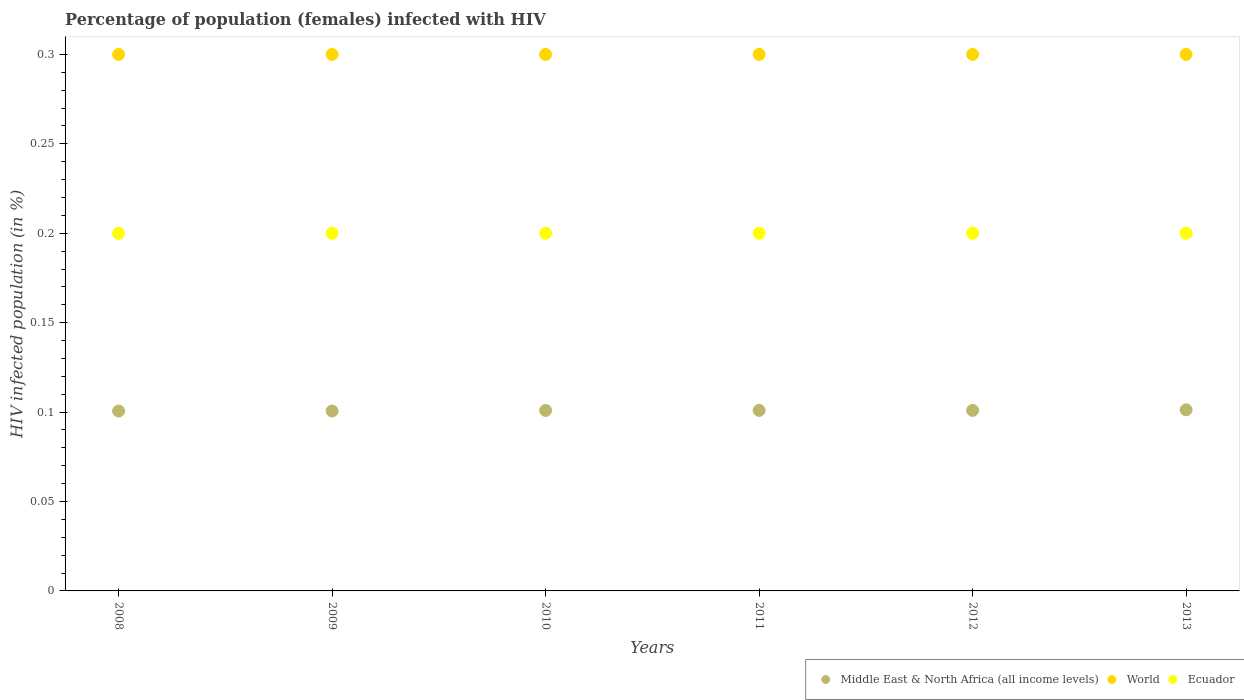Across all years, what is the maximum percentage of HIV infected female population in World?
Your answer should be compact. 0.3. Across all years, what is the minimum percentage of HIV infected female population in World?
Your response must be concise. 0.3. What is the total percentage of HIV infected female population in Middle East & North Africa (all income levels) in the graph?
Your response must be concise. 0.61. What is the difference between the percentage of HIV infected female population in Middle East & North Africa (all income levels) in 2009 and that in 2011?
Make the answer very short. -0. What is the difference between the percentage of HIV infected female population in Middle East & North Africa (all income levels) in 2009 and the percentage of HIV infected female population in World in 2010?
Ensure brevity in your answer.  -0.2. What is the average percentage of HIV infected female population in Middle East & North Africa (all income levels) per year?
Keep it short and to the point. 0.1. In the year 2009, what is the difference between the percentage of HIV infected female population in World and percentage of HIV infected female population in Middle East & North Africa (all income levels)?
Your answer should be very brief. 0.2. What is the ratio of the percentage of HIV infected female population in World in 2010 to that in 2013?
Make the answer very short. 1. What is the difference between the highest and the lowest percentage of HIV infected female population in World?
Keep it short and to the point. 0. Is the sum of the percentage of HIV infected female population in Middle East & North Africa (all income levels) in 2010 and 2012 greater than the maximum percentage of HIV infected female population in World across all years?
Your response must be concise. No. Does the percentage of HIV infected female population in World monotonically increase over the years?
Provide a short and direct response. No. Is the percentage of HIV infected female population in World strictly less than the percentage of HIV infected female population in Ecuador over the years?
Ensure brevity in your answer.  No. How many dotlines are there?
Offer a very short reply. 3. How many years are there in the graph?
Give a very brief answer. 6. What is the difference between two consecutive major ticks on the Y-axis?
Your answer should be compact. 0.05. Are the values on the major ticks of Y-axis written in scientific E-notation?
Provide a short and direct response. No. Does the graph contain grids?
Provide a short and direct response. No. How are the legend labels stacked?
Provide a succinct answer. Horizontal. What is the title of the graph?
Make the answer very short. Percentage of population (females) infected with HIV. Does "Benin" appear as one of the legend labels in the graph?
Give a very brief answer. No. What is the label or title of the X-axis?
Ensure brevity in your answer.  Years. What is the label or title of the Y-axis?
Provide a short and direct response. HIV infected population (in %). What is the HIV infected population (in %) in Middle East & North Africa (all income levels) in 2008?
Your answer should be compact. 0.1. What is the HIV infected population (in %) of Ecuador in 2008?
Your response must be concise. 0.2. What is the HIV infected population (in %) of Middle East & North Africa (all income levels) in 2009?
Offer a very short reply. 0.1. What is the HIV infected population (in %) of Middle East & North Africa (all income levels) in 2010?
Offer a very short reply. 0.1. What is the HIV infected population (in %) of Middle East & North Africa (all income levels) in 2011?
Your response must be concise. 0.1. What is the HIV infected population (in %) of Ecuador in 2011?
Keep it short and to the point. 0.2. What is the HIV infected population (in %) in Middle East & North Africa (all income levels) in 2012?
Offer a very short reply. 0.1. What is the HIV infected population (in %) of World in 2012?
Provide a short and direct response. 0.3. What is the HIV infected population (in %) in Ecuador in 2012?
Make the answer very short. 0.2. What is the HIV infected population (in %) of Middle East & North Africa (all income levels) in 2013?
Make the answer very short. 0.1. What is the HIV infected population (in %) in Ecuador in 2013?
Ensure brevity in your answer.  0.2. Across all years, what is the maximum HIV infected population (in %) in Middle East & North Africa (all income levels)?
Your response must be concise. 0.1. Across all years, what is the minimum HIV infected population (in %) of Middle East & North Africa (all income levels)?
Keep it short and to the point. 0.1. Across all years, what is the minimum HIV infected population (in %) in World?
Make the answer very short. 0.3. Across all years, what is the minimum HIV infected population (in %) in Ecuador?
Make the answer very short. 0.2. What is the total HIV infected population (in %) of Middle East & North Africa (all income levels) in the graph?
Give a very brief answer. 0.61. What is the total HIV infected population (in %) in World in the graph?
Offer a very short reply. 1.8. What is the difference between the HIV infected population (in %) of Middle East & North Africa (all income levels) in 2008 and that in 2009?
Your response must be concise. -0. What is the difference between the HIV infected population (in %) of World in 2008 and that in 2009?
Your answer should be very brief. 0. What is the difference between the HIV infected population (in %) of Ecuador in 2008 and that in 2009?
Your answer should be compact. 0. What is the difference between the HIV infected population (in %) in Middle East & North Africa (all income levels) in 2008 and that in 2010?
Provide a short and direct response. -0. What is the difference between the HIV infected population (in %) of World in 2008 and that in 2010?
Your answer should be compact. 0. What is the difference between the HIV infected population (in %) of Middle East & North Africa (all income levels) in 2008 and that in 2011?
Your answer should be very brief. -0. What is the difference between the HIV infected population (in %) of World in 2008 and that in 2011?
Your answer should be very brief. 0. What is the difference between the HIV infected population (in %) of Middle East & North Africa (all income levels) in 2008 and that in 2012?
Make the answer very short. -0. What is the difference between the HIV infected population (in %) in World in 2008 and that in 2012?
Your answer should be very brief. 0. What is the difference between the HIV infected population (in %) in Ecuador in 2008 and that in 2012?
Provide a short and direct response. 0. What is the difference between the HIV infected population (in %) in Middle East & North Africa (all income levels) in 2008 and that in 2013?
Make the answer very short. -0. What is the difference between the HIV infected population (in %) in Ecuador in 2008 and that in 2013?
Keep it short and to the point. 0. What is the difference between the HIV infected population (in %) in Middle East & North Africa (all income levels) in 2009 and that in 2010?
Ensure brevity in your answer.  -0. What is the difference between the HIV infected population (in %) in World in 2009 and that in 2010?
Give a very brief answer. 0. What is the difference between the HIV infected population (in %) of Middle East & North Africa (all income levels) in 2009 and that in 2011?
Your response must be concise. -0. What is the difference between the HIV infected population (in %) in Ecuador in 2009 and that in 2011?
Offer a terse response. 0. What is the difference between the HIV infected population (in %) in Middle East & North Africa (all income levels) in 2009 and that in 2012?
Provide a succinct answer. -0. What is the difference between the HIV infected population (in %) in Ecuador in 2009 and that in 2012?
Make the answer very short. 0. What is the difference between the HIV infected population (in %) of Middle East & North Africa (all income levels) in 2009 and that in 2013?
Give a very brief answer. -0. What is the difference between the HIV infected population (in %) of World in 2009 and that in 2013?
Your answer should be very brief. 0. What is the difference between the HIV infected population (in %) in Middle East & North Africa (all income levels) in 2010 and that in 2011?
Provide a short and direct response. -0. What is the difference between the HIV infected population (in %) in World in 2010 and that in 2011?
Give a very brief answer. 0. What is the difference between the HIV infected population (in %) of Middle East & North Africa (all income levels) in 2010 and that in 2013?
Keep it short and to the point. -0. What is the difference between the HIV infected population (in %) of Ecuador in 2010 and that in 2013?
Offer a terse response. 0. What is the difference between the HIV infected population (in %) in Middle East & North Africa (all income levels) in 2011 and that in 2013?
Make the answer very short. -0. What is the difference between the HIV infected population (in %) of Ecuador in 2011 and that in 2013?
Provide a succinct answer. 0. What is the difference between the HIV infected population (in %) of Middle East & North Africa (all income levels) in 2012 and that in 2013?
Ensure brevity in your answer.  -0. What is the difference between the HIV infected population (in %) in Ecuador in 2012 and that in 2013?
Provide a short and direct response. 0. What is the difference between the HIV infected population (in %) of Middle East & North Africa (all income levels) in 2008 and the HIV infected population (in %) of World in 2009?
Ensure brevity in your answer.  -0.2. What is the difference between the HIV infected population (in %) of Middle East & North Africa (all income levels) in 2008 and the HIV infected population (in %) of Ecuador in 2009?
Offer a very short reply. -0.1. What is the difference between the HIV infected population (in %) of World in 2008 and the HIV infected population (in %) of Ecuador in 2009?
Make the answer very short. 0.1. What is the difference between the HIV infected population (in %) of Middle East & North Africa (all income levels) in 2008 and the HIV infected population (in %) of World in 2010?
Give a very brief answer. -0.2. What is the difference between the HIV infected population (in %) of Middle East & North Africa (all income levels) in 2008 and the HIV infected population (in %) of Ecuador in 2010?
Provide a short and direct response. -0.1. What is the difference between the HIV infected population (in %) in Middle East & North Africa (all income levels) in 2008 and the HIV infected population (in %) in World in 2011?
Keep it short and to the point. -0.2. What is the difference between the HIV infected population (in %) in Middle East & North Africa (all income levels) in 2008 and the HIV infected population (in %) in Ecuador in 2011?
Offer a very short reply. -0.1. What is the difference between the HIV infected population (in %) of World in 2008 and the HIV infected population (in %) of Ecuador in 2011?
Make the answer very short. 0.1. What is the difference between the HIV infected population (in %) in Middle East & North Africa (all income levels) in 2008 and the HIV infected population (in %) in World in 2012?
Offer a very short reply. -0.2. What is the difference between the HIV infected population (in %) of Middle East & North Africa (all income levels) in 2008 and the HIV infected population (in %) of Ecuador in 2012?
Offer a very short reply. -0.1. What is the difference between the HIV infected population (in %) of Middle East & North Africa (all income levels) in 2008 and the HIV infected population (in %) of World in 2013?
Make the answer very short. -0.2. What is the difference between the HIV infected population (in %) of Middle East & North Africa (all income levels) in 2008 and the HIV infected population (in %) of Ecuador in 2013?
Your answer should be compact. -0.1. What is the difference between the HIV infected population (in %) of Middle East & North Africa (all income levels) in 2009 and the HIV infected population (in %) of World in 2010?
Provide a succinct answer. -0.2. What is the difference between the HIV infected population (in %) in Middle East & North Africa (all income levels) in 2009 and the HIV infected population (in %) in Ecuador in 2010?
Offer a very short reply. -0.1. What is the difference between the HIV infected population (in %) in Middle East & North Africa (all income levels) in 2009 and the HIV infected population (in %) in World in 2011?
Your response must be concise. -0.2. What is the difference between the HIV infected population (in %) in Middle East & North Africa (all income levels) in 2009 and the HIV infected population (in %) in Ecuador in 2011?
Your answer should be very brief. -0.1. What is the difference between the HIV infected population (in %) in Middle East & North Africa (all income levels) in 2009 and the HIV infected population (in %) in World in 2012?
Offer a very short reply. -0.2. What is the difference between the HIV infected population (in %) of Middle East & North Africa (all income levels) in 2009 and the HIV infected population (in %) of Ecuador in 2012?
Offer a very short reply. -0.1. What is the difference between the HIV infected population (in %) of Middle East & North Africa (all income levels) in 2009 and the HIV infected population (in %) of World in 2013?
Give a very brief answer. -0.2. What is the difference between the HIV infected population (in %) of Middle East & North Africa (all income levels) in 2009 and the HIV infected population (in %) of Ecuador in 2013?
Offer a very short reply. -0.1. What is the difference between the HIV infected population (in %) in Middle East & North Africa (all income levels) in 2010 and the HIV infected population (in %) in World in 2011?
Provide a succinct answer. -0.2. What is the difference between the HIV infected population (in %) in Middle East & North Africa (all income levels) in 2010 and the HIV infected population (in %) in Ecuador in 2011?
Ensure brevity in your answer.  -0.1. What is the difference between the HIV infected population (in %) in Middle East & North Africa (all income levels) in 2010 and the HIV infected population (in %) in World in 2012?
Ensure brevity in your answer.  -0.2. What is the difference between the HIV infected population (in %) in Middle East & North Africa (all income levels) in 2010 and the HIV infected population (in %) in Ecuador in 2012?
Your response must be concise. -0.1. What is the difference between the HIV infected population (in %) in World in 2010 and the HIV infected population (in %) in Ecuador in 2012?
Your answer should be very brief. 0.1. What is the difference between the HIV infected population (in %) of Middle East & North Africa (all income levels) in 2010 and the HIV infected population (in %) of World in 2013?
Give a very brief answer. -0.2. What is the difference between the HIV infected population (in %) of Middle East & North Africa (all income levels) in 2010 and the HIV infected population (in %) of Ecuador in 2013?
Your answer should be very brief. -0.1. What is the difference between the HIV infected population (in %) of World in 2010 and the HIV infected population (in %) of Ecuador in 2013?
Keep it short and to the point. 0.1. What is the difference between the HIV infected population (in %) of Middle East & North Africa (all income levels) in 2011 and the HIV infected population (in %) of World in 2012?
Offer a terse response. -0.2. What is the difference between the HIV infected population (in %) in Middle East & North Africa (all income levels) in 2011 and the HIV infected population (in %) in Ecuador in 2012?
Make the answer very short. -0.1. What is the difference between the HIV infected population (in %) in Middle East & North Africa (all income levels) in 2011 and the HIV infected population (in %) in World in 2013?
Your response must be concise. -0.2. What is the difference between the HIV infected population (in %) in Middle East & North Africa (all income levels) in 2011 and the HIV infected population (in %) in Ecuador in 2013?
Give a very brief answer. -0.1. What is the difference between the HIV infected population (in %) in Middle East & North Africa (all income levels) in 2012 and the HIV infected population (in %) in World in 2013?
Offer a very short reply. -0.2. What is the difference between the HIV infected population (in %) in Middle East & North Africa (all income levels) in 2012 and the HIV infected population (in %) in Ecuador in 2013?
Keep it short and to the point. -0.1. What is the difference between the HIV infected population (in %) of World in 2012 and the HIV infected population (in %) of Ecuador in 2013?
Give a very brief answer. 0.1. What is the average HIV infected population (in %) in Middle East & North Africa (all income levels) per year?
Provide a short and direct response. 0.1. What is the average HIV infected population (in %) of World per year?
Provide a short and direct response. 0.3. In the year 2008, what is the difference between the HIV infected population (in %) in Middle East & North Africa (all income levels) and HIV infected population (in %) in World?
Offer a very short reply. -0.2. In the year 2008, what is the difference between the HIV infected population (in %) of Middle East & North Africa (all income levels) and HIV infected population (in %) of Ecuador?
Your answer should be compact. -0.1. In the year 2008, what is the difference between the HIV infected population (in %) of World and HIV infected population (in %) of Ecuador?
Your response must be concise. 0.1. In the year 2009, what is the difference between the HIV infected population (in %) in Middle East & North Africa (all income levels) and HIV infected population (in %) in World?
Make the answer very short. -0.2. In the year 2009, what is the difference between the HIV infected population (in %) of Middle East & North Africa (all income levels) and HIV infected population (in %) of Ecuador?
Give a very brief answer. -0.1. In the year 2010, what is the difference between the HIV infected population (in %) of Middle East & North Africa (all income levels) and HIV infected population (in %) of World?
Keep it short and to the point. -0.2. In the year 2010, what is the difference between the HIV infected population (in %) of Middle East & North Africa (all income levels) and HIV infected population (in %) of Ecuador?
Offer a very short reply. -0.1. In the year 2011, what is the difference between the HIV infected population (in %) in Middle East & North Africa (all income levels) and HIV infected population (in %) in World?
Your answer should be very brief. -0.2. In the year 2011, what is the difference between the HIV infected population (in %) of Middle East & North Africa (all income levels) and HIV infected population (in %) of Ecuador?
Ensure brevity in your answer.  -0.1. In the year 2011, what is the difference between the HIV infected population (in %) in World and HIV infected population (in %) in Ecuador?
Give a very brief answer. 0.1. In the year 2012, what is the difference between the HIV infected population (in %) in Middle East & North Africa (all income levels) and HIV infected population (in %) in World?
Your answer should be very brief. -0.2. In the year 2012, what is the difference between the HIV infected population (in %) in Middle East & North Africa (all income levels) and HIV infected population (in %) in Ecuador?
Give a very brief answer. -0.1. In the year 2012, what is the difference between the HIV infected population (in %) of World and HIV infected population (in %) of Ecuador?
Ensure brevity in your answer.  0.1. In the year 2013, what is the difference between the HIV infected population (in %) in Middle East & North Africa (all income levels) and HIV infected population (in %) in World?
Give a very brief answer. -0.2. In the year 2013, what is the difference between the HIV infected population (in %) of Middle East & North Africa (all income levels) and HIV infected population (in %) of Ecuador?
Your response must be concise. -0.1. What is the ratio of the HIV infected population (in %) in Middle East & North Africa (all income levels) in 2008 to that in 2009?
Give a very brief answer. 1. What is the ratio of the HIV infected population (in %) in World in 2008 to that in 2009?
Your answer should be compact. 1. What is the ratio of the HIV infected population (in %) in Ecuador in 2008 to that in 2009?
Your answer should be compact. 1. What is the ratio of the HIV infected population (in %) of Ecuador in 2008 to that in 2010?
Your answer should be very brief. 1. What is the ratio of the HIV infected population (in %) of Ecuador in 2008 to that in 2011?
Keep it short and to the point. 1. What is the ratio of the HIV infected population (in %) of World in 2008 to that in 2012?
Ensure brevity in your answer.  1. What is the ratio of the HIV infected population (in %) in World in 2008 to that in 2013?
Provide a succinct answer. 1. What is the ratio of the HIV infected population (in %) of Ecuador in 2008 to that in 2013?
Make the answer very short. 1. What is the ratio of the HIV infected population (in %) in Middle East & North Africa (all income levels) in 2009 to that in 2010?
Make the answer very short. 1. What is the ratio of the HIV infected population (in %) in World in 2009 to that in 2010?
Provide a succinct answer. 1. What is the ratio of the HIV infected population (in %) of Middle East & North Africa (all income levels) in 2009 to that in 2011?
Keep it short and to the point. 1. What is the ratio of the HIV infected population (in %) in World in 2009 to that in 2011?
Offer a terse response. 1. What is the ratio of the HIV infected population (in %) in Ecuador in 2009 to that in 2011?
Make the answer very short. 1. What is the ratio of the HIV infected population (in %) of Middle East & North Africa (all income levels) in 2009 to that in 2013?
Offer a very short reply. 0.99. What is the ratio of the HIV infected population (in %) in Ecuador in 2010 to that in 2011?
Provide a short and direct response. 1. What is the ratio of the HIV infected population (in %) of Middle East & North Africa (all income levels) in 2010 to that in 2012?
Ensure brevity in your answer.  1. What is the ratio of the HIV infected population (in %) of World in 2010 to that in 2012?
Your answer should be compact. 1. What is the ratio of the HIV infected population (in %) in Middle East & North Africa (all income levels) in 2011 to that in 2012?
Give a very brief answer. 1. What is the ratio of the HIV infected population (in %) in World in 2011 to that in 2012?
Your answer should be very brief. 1. What is the ratio of the HIV infected population (in %) of Middle East & North Africa (all income levels) in 2011 to that in 2013?
Make the answer very short. 1. What is the ratio of the HIV infected population (in %) in Ecuador in 2011 to that in 2013?
Your answer should be compact. 1. What is the ratio of the HIV infected population (in %) of World in 2012 to that in 2013?
Make the answer very short. 1. What is the ratio of the HIV infected population (in %) of Ecuador in 2012 to that in 2013?
Offer a very short reply. 1. What is the difference between the highest and the lowest HIV infected population (in %) of Middle East & North Africa (all income levels)?
Give a very brief answer. 0. What is the difference between the highest and the lowest HIV infected population (in %) of World?
Make the answer very short. 0. What is the difference between the highest and the lowest HIV infected population (in %) in Ecuador?
Ensure brevity in your answer.  0. 